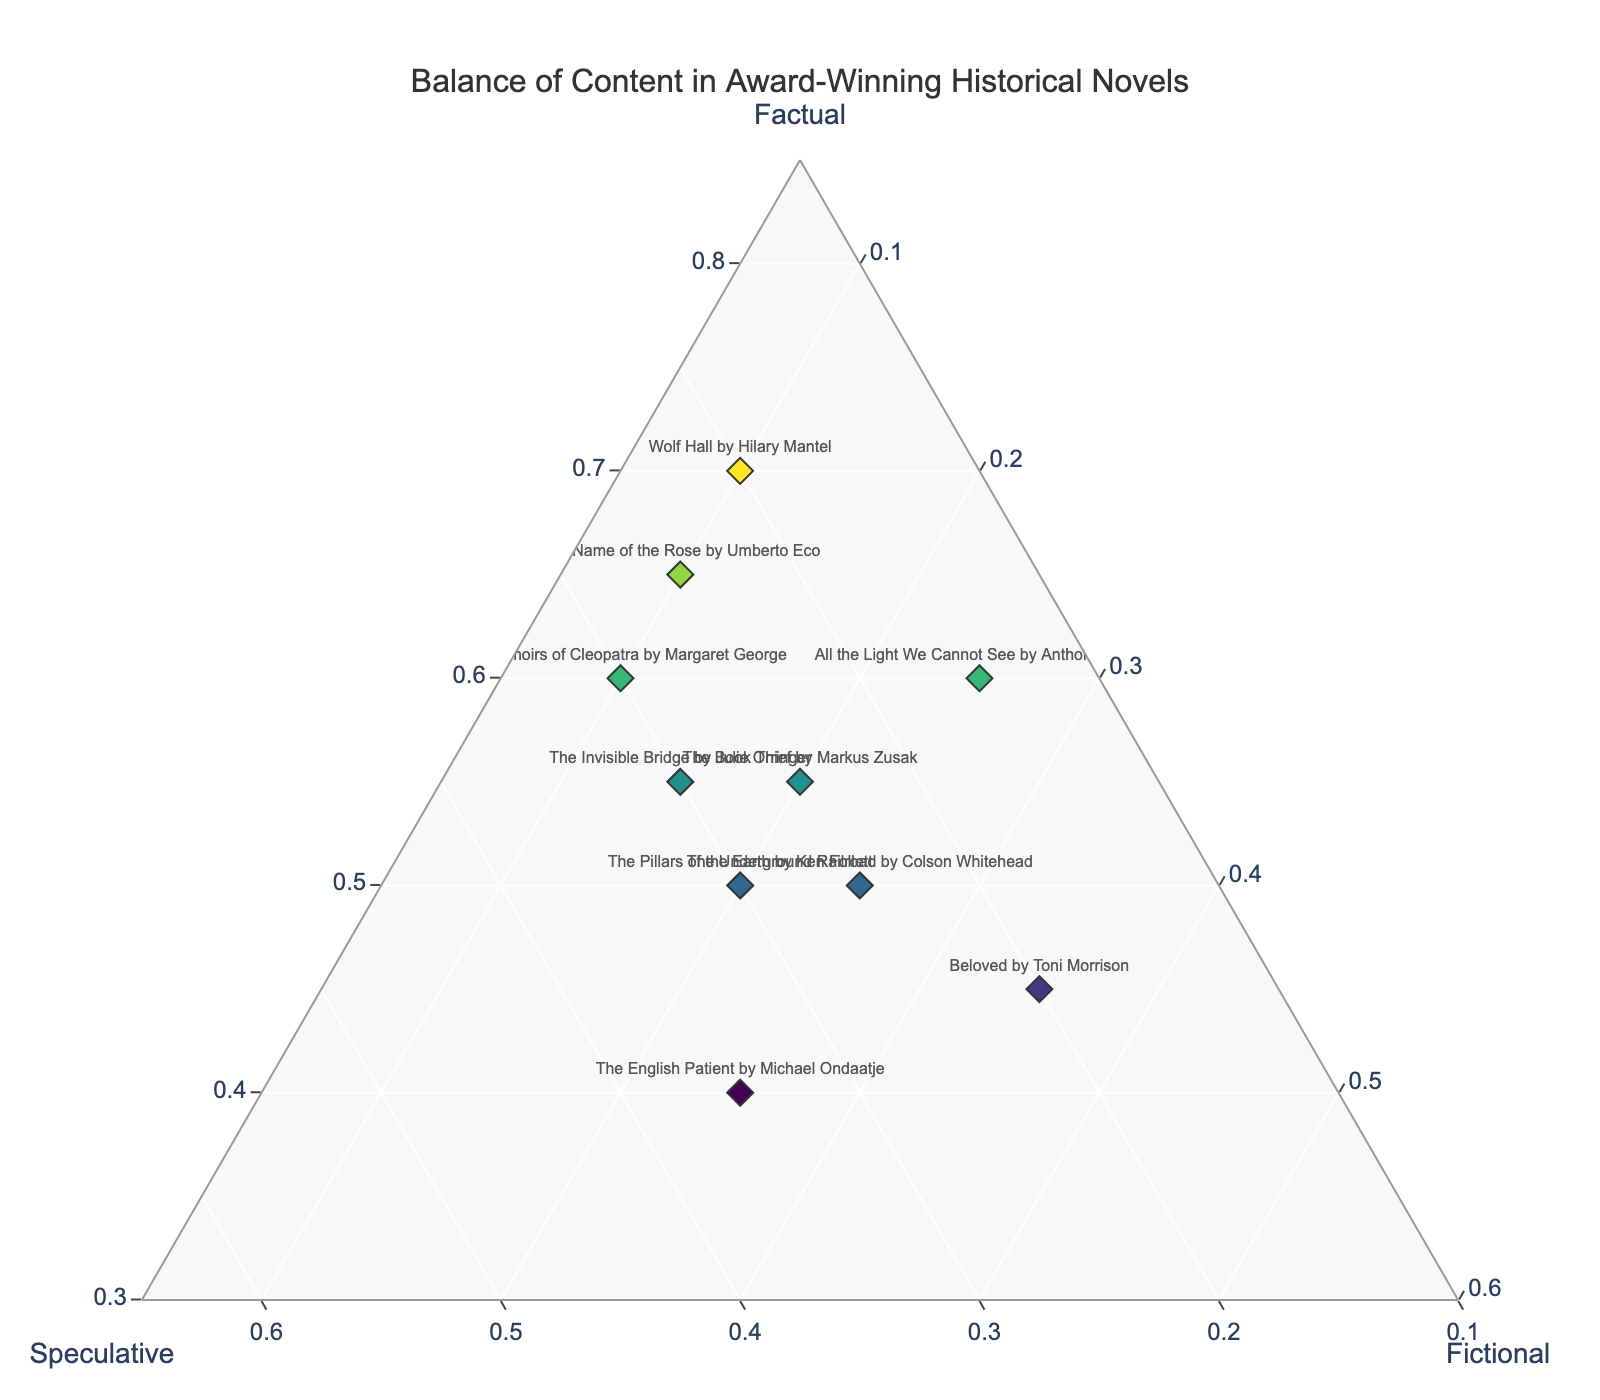Who wrote "The Book Thief" and what is its approximate balance of content? The Ternary plot shows the text label representing "The Book Thief" by Markus Zusak and its corresponding hover template percentages: Factual: 55%, Speculative: 25%, and Fictional: 20%.
Answer: Markus Zusak, Factual: 55%, Speculative: 25%, Fictional: 20% Which novel has the highest factual content and what are its exact values? According to the Ternary Plot, "Wolf Hall" by Hilary Mantel has the highest factual content with exact values shown in the hover template: Factual: 70%, Speculative: 20%, and Fictional: 10%.
Answer: "Wolf Hall" by Hilary Mantel, Factual: 70% What is the title with the least balance towards speculative content and its values? The Ternary plot shows that "All the Light We Cannot See" by Anthony Doerr has the least speculative content as visible in its hover template percentage: Speculative: 15%.
Answer: "All the Light We Cannot See" by Anthony Doerr, Speculative: 15% Identify the novels that have equal fictional content and their respective balances. "All the Light We Cannot See" by Anthony Doerr and "The Memoirs of Cleopatra" by Margaret George both have 10% fictional content as seen in the plot's hover template. Their balances for the other elements are 25% in speculative and 60% in factual for "The Memoirs of Cleopatra" whereas "All the Light We Cannot See" has 25% fictional and 15% speculative.
Answer: "All the Light We Cannot See" and "The Memoirs of Cleopatra", Fictional: 10% Compute the average value of factual content across all novels. The factual values from the dataset are: 70, 55, 60, 50, 65, 45, 40, 55, 50, and 60. Summing these gives us 550. Dividing by the number of novels (10), the average factual content is 550 / 10 = 55%.
Answer: 55% Which novel lies at the intersection where speculative and fictional content are equal; what is its factual percentage? "The Underground Railroad" by Colson Whitehead is at the intersection with speculative and fictional content both at 25%, with the factual content at 50% as shown in its hover template.
Answer: "The Underground Railroad" by Colson Whitehead, Factual: 50% What is the range of speculative content values among these novels? The speculative content values from the dataset are: 20, 25, 15, 30, 25, 20, 35, 30, 25, and 30. The highest value is 35% and the lowest is 15%. Therefore, the range is 35% - 15% = 20%.
Answer: 20% How many novels have at least 50% factual content? The ternary plot shows that there are eight novels with at least 50% factual content: "Wolf Hall", "The Book Thief", "All the Light We Cannot See", "The Name of the Rose", "The Invisible Bridge", "The Memoirs of Cleopatra", "The Pillars of the Earth", and "The Underground Railroad".
Answer: 8 Identify the novel with the most balanced distribution of content and state the values for factual, speculative, and fictional. "The English Patient" by Michael Ondaatje has the most balanced distribution of content among the three aspects shown by its hover template: Factual: 40%, Speculative: 35%, and Fictional: 25%.
Answer: "The English Patient" by Michael Ondaatje, Factual: 40%, Speculative: 35%, Fictional: 25% What is the combined percentage of speculative and fictional content for "The Name of the Rose"? The speculative content is 25% and the fictional content is 10%. Adding these gives 25% + 10% = 35%.
Answer: 35% 